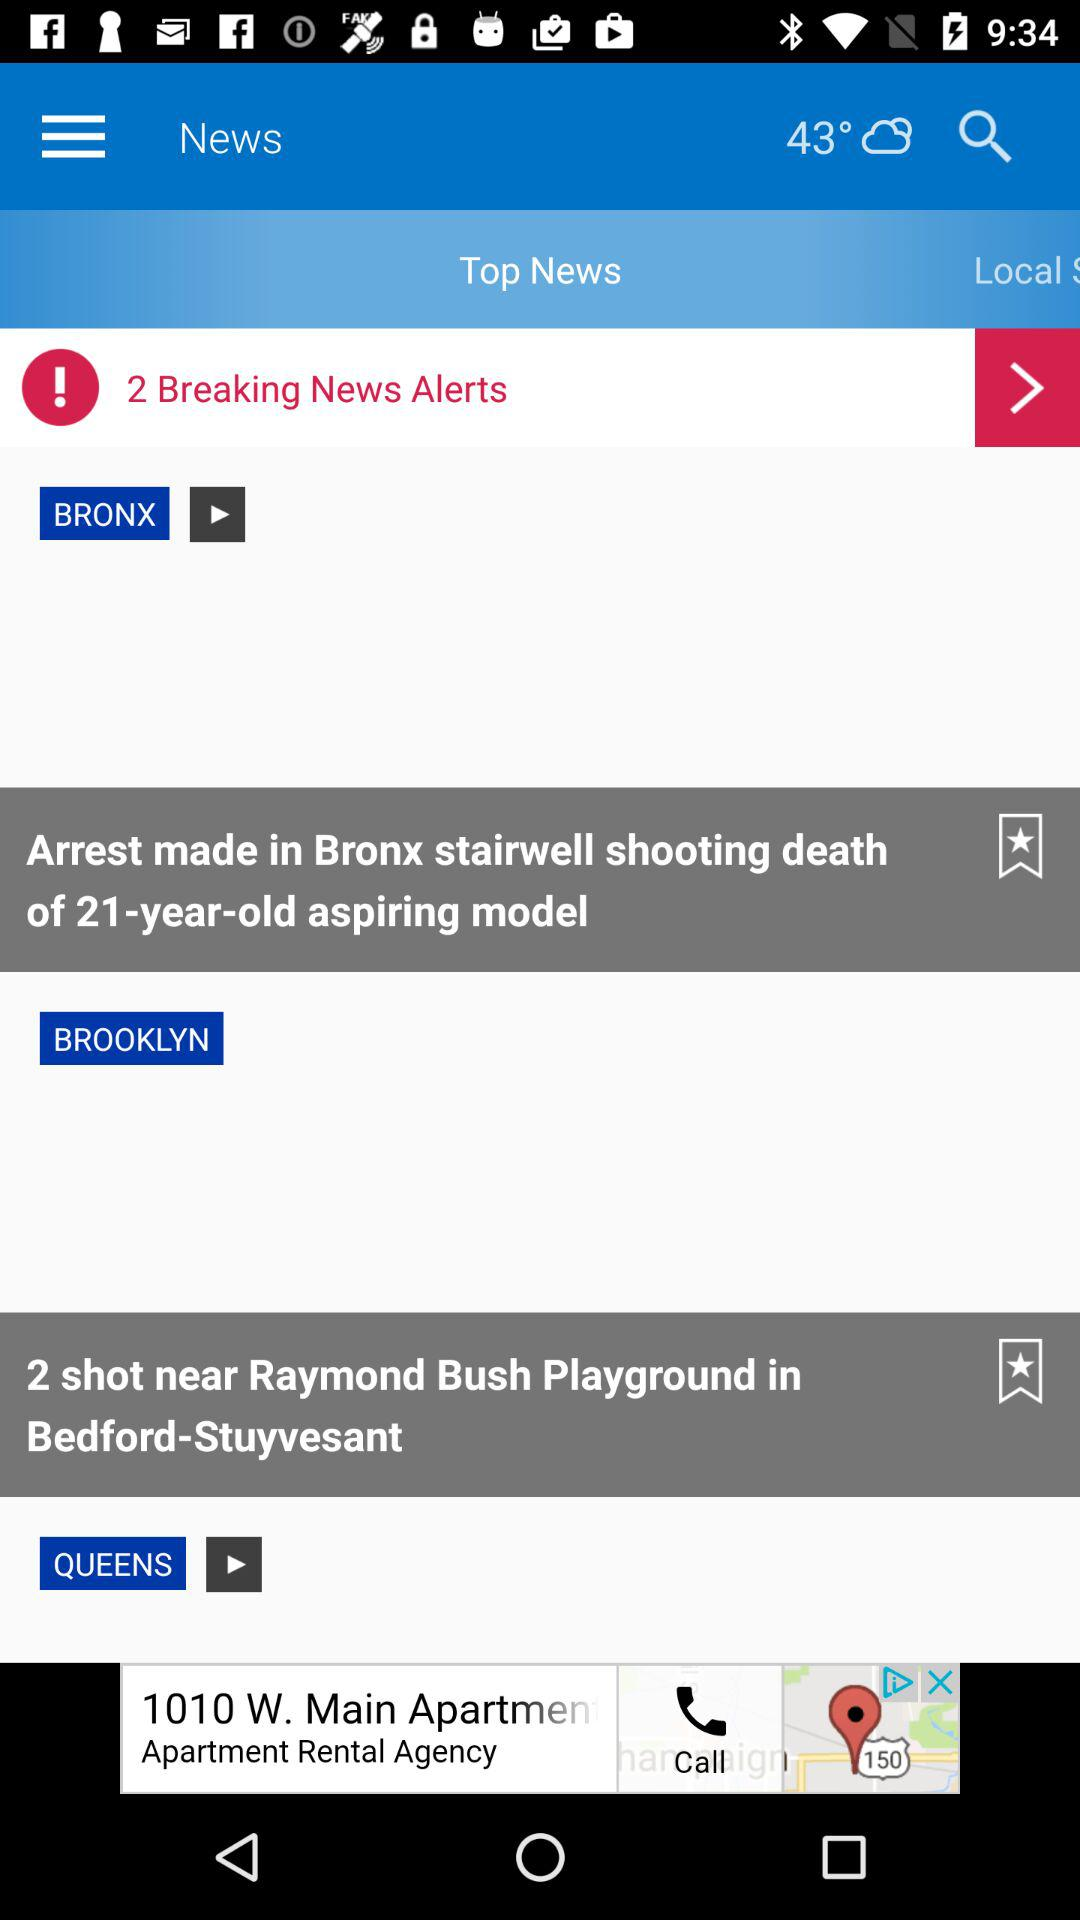What is the displayed temperature? The displayed temperature is 43°. 